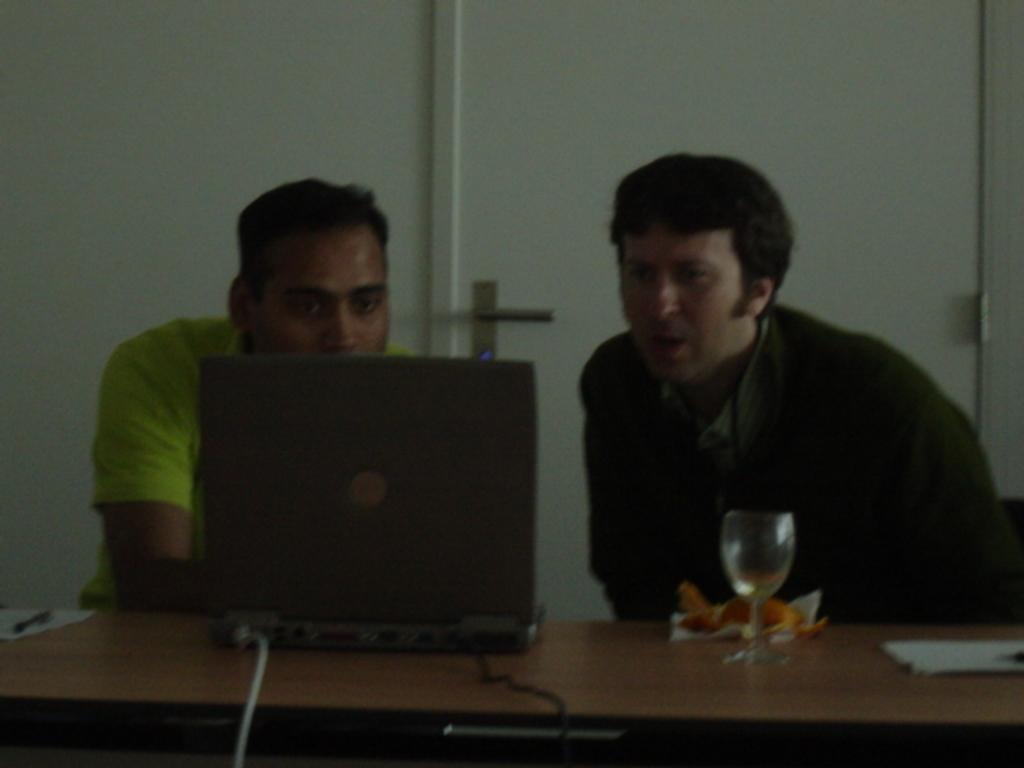How many people are sitting in the chair in the image? There are two persons sitting in a chair in the image. What electronic device is on the table? There is a laptop on the table. What type of container is on the table? There is a glass on the table. What item is used for cleaning or wiping on the table? There is a tissue on the table. What architectural feature is present in the image? There is a door in the image. What type of fruit is being produced by the tree in the image? There is no tree or fruit present in the image. What is the top of the door made of in the image? The image does not provide information about the material of the door or its top. 